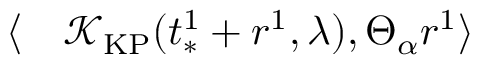Convert formula to latex. <formula><loc_0><loc_0><loc_500><loc_500>\begin{array} { r l } { \langle } & \mathcal { K } _ { K P } ( t _ { * } ^ { 1 } + r ^ { 1 } , \lambda ) , \Theta _ { \alpha } r ^ { 1 } \rangle } \end{array}</formula> 